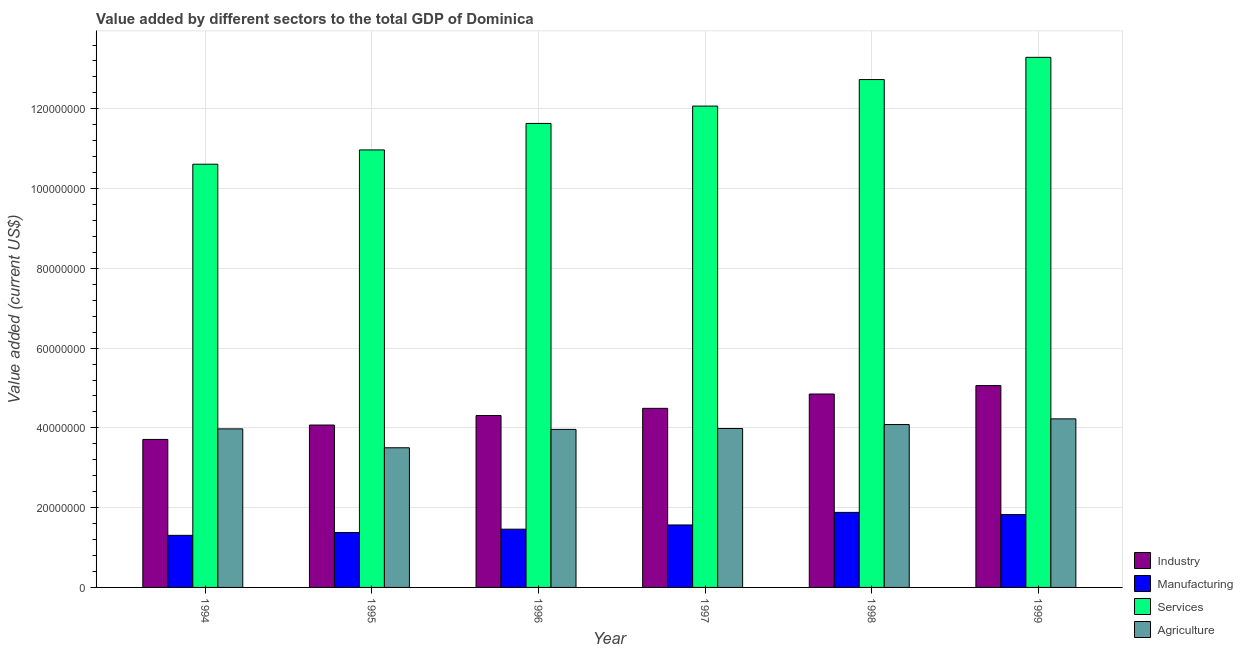How many groups of bars are there?
Your answer should be very brief. 6. Are the number of bars on each tick of the X-axis equal?
Provide a succinct answer. Yes. What is the label of the 4th group of bars from the left?
Offer a terse response. 1997. What is the value added by agricultural sector in 1994?
Your answer should be compact. 3.98e+07. Across all years, what is the maximum value added by manufacturing sector?
Your response must be concise. 1.88e+07. Across all years, what is the minimum value added by services sector?
Your answer should be very brief. 1.06e+08. In which year was the value added by agricultural sector maximum?
Offer a very short reply. 1999. What is the total value added by services sector in the graph?
Your answer should be very brief. 7.13e+08. What is the difference between the value added by industrial sector in 1995 and that in 1996?
Offer a terse response. -2.38e+06. What is the difference between the value added by services sector in 1995 and the value added by manufacturing sector in 1994?
Provide a short and direct response. 3.58e+06. What is the average value added by services sector per year?
Make the answer very short. 1.19e+08. In the year 1997, what is the difference between the value added by agricultural sector and value added by manufacturing sector?
Make the answer very short. 0. What is the ratio of the value added by industrial sector in 1995 to that in 1997?
Ensure brevity in your answer.  0.91. What is the difference between the highest and the second highest value added by services sector?
Offer a terse response. 5.57e+06. What is the difference between the highest and the lowest value added by services sector?
Make the answer very short. 2.68e+07. In how many years, is the value added by industrial sector greater than the average value added by industrial sector taken over all years?
Offer a very short reply. 3. Is it the case that in every year, the sum of the value added by services sector and value added by agricultural sector is greater than the sum of value added by manufacturing sector and value added by industrial sector?
Provide a succinct answer. Yes. What does the 2nd bar from the left in 1994 represents?
Your answer should be compact. Manufacturing. What does the 3rd bar from the right in 1997 represents?
Offer a terse response. Manufacturing. Is it the case that in every year, the sum of the value added by industrial sector and value added by manufacturing sector is greater than the value added by services sector?
Make the answer very short. No. How many years are there in the graph?
Your response must be concise. 6. What is the difference between two consecutive major ticks on the Y-axis?
Make the answer very short. 2.00e+07. Does the graph contain any zero values?
Your response must be concise. No. Does the graph contain grids?
Offer a very short reply. Yes. What is the title of the graph?
Offer a terse response. Value added by different sectors to the total GDP of Dominica. Does "Methodology assessment" appear as one of the legend labels in the graph?
Your response must be concise. No. What is the label or title of the X-axis?
Offer a very short reply. Year. What is the label or title of the Y-axis?
Keep it short and to the point. Value added (current US$). What is the Value added (current US$) in Industry in 1994?
Your answer should be very brief. 3.71e+07. What is the Value added (current US$) in Manufacturing in 1994?
Offer a very short reply. 1.31e+07. What is the Value added (current US$) of Services in 1994?
Make the answer very short. 1.06e+08. What is the Value added (current US$) in Agriculture in 1994?
Offer a very short reply. 3.98e+07. What is the Value added (current US$) of Industry in 1995?
Your answer should be compact. 4.07e+07. What is the Value added (current US$) in Manufacturing in 1995?
Your answer should be compact. 1.38e+07. What is the Value added (current US$) of Services in 1995?
Your response must be concise. 1.10e+08. What is the Value added (current US$) of Agriculture in 1995?
Give a very brief answer. 3.50e+07. What is the Value added (current US$) in Industry in 1996?
Offer a terse response. 4.31e+07. What is the Value added (current US$) in Manufacturing in 1996?
Keep it short and to the point. 1.46e+07. What is the Value added (current US$) in Services in 1996?
Offer a terse response. 1.16e+08. What is the Value added (current US$) of Agriculture in 1996?
Provide a short and direct response. 3.96e+07. What is the Value added (current US$) in Industry in 1997?
Your answer should be very brief. 4.49e+07. What is the Value added (current US$) in Manufacturing in 1997?
Give a very brief answer. 1.57e+07. What is the Value added (current US$) of Services in 1997?
Your answer should be very brief. 1.21e+08. What is the Value added (current US$) of Agriculture in 1997?
Ensure brevity in your answer.  3.98e+07. What is the Value added (current US$) in Industry in 1998?
Give a very brief answer. 4.85e+07. What is the Value added (current US$) in Manufacturing in 1998?
Provide a short and direct response. 1.88e+07. What is the Value added (current US$) in Services in 1998?
Provide a succinct answer. 1.27e+08. What is the Value added (current US$) of Agriculture in 1998?
Make the answer very short. 4.08e+07. What is the Value added (current US$) in Industry in 1999?
Your response must be concise. 5.06e+07. What is the Value added (current US$) of Manufacturing in 1999?
Keep it short and to the point. 1.83e+07. What is the Value added (current US$) of Services in 1999?
Ensure brevity in your answer.  1.33e+08. What is the Value added (current US$) in Agriculture in 1999?
Your response must be concise. 4.23e+07. Across all years, what is the maximum Value added (current US$) of Industry?
Your response must be concise. 5.06e+07. Across all years, what is the maximum Value added (current US$) of Manufacturing?
Keep it short and to the point. 1.88e+07. Across all years, what is the maximum Value added (current US$) in Services?
Give a very brief answer. 1.33e+08. Across all years, what is the maximum Value added (current US$) in Agriculture?
Provide a succinct answer. 4.23e+07. Across all years, what is the minimum Value added (current US$) of Industry?
Your response must be concise. 3.71e+07. Across all years, what is the minimum Value added (current US$) of Manufacturing?
Provide a succinct answer. 1.31e+07. Across all years, what is the minimum Value added (current US$) of Services?
Your answer should be compact. 1.06e+08. Across all years, what is the minimum Value added (current US$) of Agriculture?
Offer a very short reply. 3.50e+07. What is the total Value added (current US$) in Industry in the graph?
Make the answer very short. 2.65e+08. What is the total Value added (current US$) in Manufacturing in the graph?
Keep it short and to the point. 9.42e+07. What is the total Value added (current US$) in Services in the graph?
Provide a short and direct response. 7.13e+08. What is the total Value added (current US$) in Agriculture in the graph?
Your response must be concise. 2.37e+08. What is the difference between the Value added (current US$) of Industry in 1994 and that in 1995?
Offer a very short reply. -3.61e+06. What is the difference between the Value added (current US$) in Manufacturing in 1994 and that in 1995?
Make the answer very short. -7.04e+05. What is the difference between the Value added (current US$) in Services in 1994 and that in 1995?
Offer a very short reply. -3.58e+06. What is the difference between the Value added (current US$) in Agriculture in 1994 and that in 1995?
Provide a short and direct response. 4.74e+06. What is the difference between the Value added (current US$) of Industry in 1994 and that in 1996?
Your response must be concise. -5.99e+06. What is the difference between the Value added (current US$) in Manufacturing in 1994 and that in 1996?
Offer a very short reply. -1.54e+06. What is the difference between the Value added (current US$) in Services in 1994 and that in 1996?
Your answer should be compact. -1.02e+07. What is the difference between the Value added (current US$) of Agriculture in 1994 and that in 1996?
Provide a short and direct response. 1.30e+05. What is the difference between the Value added (current US$) in Industry in 1994 and that in 1997?
Offer a terse response. -7.80e+06. What is the difference between the Value added (current US$) of Manufacturing in 1994 and that in 1997?
Keep it short and to the point. -2.60e+06. What is the difference between the Value added (current US$) in Services in 1994 and that in 1997?
Offer a terse response. -1.46e+07. What is the difference between the Value added (current US$) in Agriculture in 1994 and that in 1997?
Offer a very short reply. -8.89e+04. What is the difference between the Value added (current US$) in Industry in 1994 and that in 1998?
Give a very brief answer. -1.14e+07. What is the difference between the Value added (current US$) in Manufacturing in 1994 and that in 1998?
Ensure brevity in your answer.  -5.75e+06. What is the difference between the Value added (current US$) in Services in 1994 and that in 1998?
Provide a short and direct response. -2.12e+07. What is the difference between the Value added (current US$) of Agriculture in 1994 and that in 1998?
Offer a terse response. -1.09e+06. What is the difference between the Value added (current US$) in Industry in 1994 and that in 1999?
Offer a terse response. -1.35e+07. What is the difference between the Value added (current US$) in Manufacturing in 1994 and that in 1999?
Keep it short and to the point. -5.20e+06. What is the difference between the Value added (current US$) of Services in 1994 and that in 1999?
Offer a terse response. -2.68e+07. What is the difference between the Value added (current US$) in Agriculture in 1994 and that in 1999?
Your response must be concise. -2.51e+06. What is the difference between the Value added (current US$) in Industry in 1995 and that in 1996?
Make the answer very short. -2.38e+06. What is the difference between the Value added (current US$) in Manufacturing in 1995 and that in 1996?
Give a very brief answer. -8.37e+05. What is the difference between the Value added (current US$) in Services in 1995 and that in 1996?
Provide a short and direct response. -6.64e+06. What is the difference between the Value added (current US$) of Agriculture in 1995 and that in 1996?
Offer a very short reply. -4.61e+06. What is the difference between the Value added (current US$) of Industry in 1995 and that in 1997?
Provide a succinct answer. -4.19e+06. What is the difference between the Value added (current US$) in Manufacturing in 1995 and that in 1997?
Your answer should be compact. -1.90e+06. What is the difference between the Value added (current US$) in Services in 1995 and that in 1997?
Offer a terse response. -1.10e+07. What is the difference between the Value added (current US$) of Agriculture in 1995 and that in 1997?
Your answer should be compact. -4.83e+06. What is the difference between the Value added (current US$) in Industry in 1995 and that in 1998?
Give a very brief answer. -7.78e+06. What is the difference between the Value added (current US$) of Manufacturing in 1995 and that in 1998?
Provide a short and direct response. -5.05e+06. What is the difference between the Value added (current US$) in Services in 1995 and that in 1998?
Provide a short and direct response. -1.76e+07. What is the difference between the Value added (current US$) in Agriculture in 1995 and that in 1998?
Give a very brief answer. -5.82e+06. What is the difference between the Value added (current US$) in Industry in 1995 and that in 1999?
Offer a very short reply. -9.89e+06. What is the difference between the Value added (current US$) in Manufacturing in 1995 and that in 1999?
Provide a succinct answer. -4.49e+06. What is the difference between the Value added (current US$) of Services in 1995 and that in 1999?
Keep it short and to the point. -2.32e+07. What is the difference between the Value added (current US$) of Agriculture in 1995 and that in 1999?
Offer a terse response. -7.25e+06. What is the difference between the Value added (current US$) of Industry in 1996 and that in 1997?
Your answer should be very brief. -1.81e+06. What is the difference between the Value added (current US$) in Manufacturing in 1996 and that in 1997?
Keep it short and to the point. -1.06e+06. What is the difference between the Value added (current US$) in Services in 1996 and that in 1997?
Provide a succinct answer. -4.35e+06. What is the difference between the Value added (current US$) of Agriculture in 1996 and that in 1997?
Make the answer very short. -2.19e+05. What is the difference between the Value added (current US$) of Industry in 1996 and that in 1998?
Offer a terse response. -5.40e+06. What is the difference between the Value added (current US$) of Manufacturing in 1996 and that in 1998?
Your answer should be compact. -4.21e+06. What is the difference between the Value added (current US$) of Services in 1996 and that in 1998?
Provide a short and direct response. -1.10e+07. What is the difference between the Value added (current US$) of Agriculture in 1996 and that in 1998?
Your response must be concise. -1.21e+06. What is the difference between the Value added (current US$) of Industry in 1996 and that in 1999?
Your response must be concise. -7.51e+06. What is the difference between the Value added (current US$) in Manufacturing in 1996 and that in 1999?
Keep it short and to the point. -3.66e+06. What is the difference between the Value added (current US$) in Services in 1996 and that in 1999?
Your answer should be very brief. -1.66e+07. What is the difference between the Value added (current US$) of Agriculture in 1996 and that in 1999?
Ensure brevity in your answer.  -2.64e+06. What is the difference between the Value added (current US$) in Industry in 1997 and that in 1998?
Offer a very short reply. -3.59e+06. What is the difference between the Value added (current US$) in Manufacturing in 1997 and that in 1998?
Your answer should be compact. -3.15e+06. What is the difference between the Value added (current US$) of Services in 1997 and that in 1998?
Provide a short and direct response. -6.65e+06. What is the difference between the Value added (current US$) of Agriculture in 1997 and that in 1998?
Offer a very short reply. -9.96e+05. What is the difference between the Value added (current US$) of Industry in 1997 and that in 1999?
Keep it short and to the point. -5.70e+06. What is the difference between the Value added (current US$) in Manufacturing in 1997 and that in 1999?
Your response must be concise. -2.60e+06. What is the difference between the Value added (current US$) in Services in 1997 and that in 1999?
Offer a very short reply. -1.22e+07. What is the difference between the Value added (current US$) of Agriculture in 1997 and that in 1999?
Provide a short and direct response. -2.42e+06. What is the difference between the Value added (current US$) of Industry in 1998 and that in 1999?
Provide a short and direct response. -2.11e+06. What is the difference between the Value added (current US$) in Manufacturing in 1998 and that in 1999?
Keep it short and to the point. 5.56e+05. What is the difference between the Value added (current US$) in Services in 1998 and that in 1999?
Provide a short and direct response. -5.57e+06. What is the difference between the Value added (current US$) of Agriculture in 1998 and that in 1999?
Offer a terse response. -1.43e+06. What is the difference between the Value added (current US$) of Industry in 1994 and the Value added (current US$) of Manufacturing in 1995?
Your answer should be very brief. 2.33e+07. What is the difference between the Value added (current US$) in Industry in 1994 and the Value added (current US$) in Services in 1995?
Give a very brief answer. -7.26e+07. What is the difference between the Value added (current US$) in Industry in 1994 and the Value added (current US$) in Agriculture in 1995?
Make the answer very short. 2.09e+06. What is the difference between the Value added (current US$) of Manufacturing in 1994 and the Value added (current US$) of Services in 1995?
Give a very brief answer. -9.66e+07. What is the difference between the Value added (current US$) in Manufacturing in 1994 and the Value added (current US$) in Agriculture in 1995?
Offer a terse response. -2.20e+07. What is the difference between the Value added (current US$) of Services in 1994 and the Value added (current US$) of Agriculture in 1995?
Keep it short and to the point. 7.11e+07. What is the difference between the Value added (current US$) of Industry in 1994 and the Value added (current US$) of Manufacturing in 1996?
Ensure brevity in your answer.  2.25e+07. What is the difference between the Value added (current US$) in Industry in 1994 and the Value added (current US$) in Services in 1996?
Ensure brevity in your answer.  -7.92e+07. What is the difference between the Value added (current US$) of Industry in 1994 and the Value added (current US$) of Agriculture in 1996?
Offer a very short reply. -2.51e+06. What is the difference between the Value added (current US$) in Manufacturing in 1994 and the Value added (current US$) in Services in 1996?
Offer a terse response. -1.03e+08. What is the difference between the Value added (current US$) in Manufacturing in 1994 and the Value added (current US$) in Agriculture in 1996?
Offer a terse response. -2.66e+07. What is the difference between the Value added (current US$) in Services in 1994 and the Value added (current US$) in Agriculture in 1996?
Make the answer very short. 6.65e+07. What is the difference between the Value added (current US$) of Industry in 1994 and the Value added (current US$) of Manufacturing in 1997?
Offer a very short reply. 2.14e+07. What is the difference between the Value added (current US$) of Industry in 1994 and the Value added (current US$) of Services in 1997?
Your response must be concise. -8.36e+07. What is the difference between the Value added (current US$) in Industry in 1994 and the Value added (current US$) in Agriculture in 1997?
Offer a terse response. -2.73e+06. What is the difference between the Value added (current US$) of Manufacturing in 1994 and the Value added (current US$) of Services in 1997?
Ensure brevity in your answer.  -1.08e+08. What is the difference between the Value added (current US$) of Manufacturing in 1994 and the Value added (current US$) of Agriculture in 1997?
Your answer should be compact. -2.68e+07. What is the difference between the Value added (current US$) of Services in 1994 and the Value added (current US$) of Agriculture in 1997?
Provide a short and direct response. 6.63e+07. What is the difference between the Value added (current US$) of Industry in 1994 and the Value added (current US$) of Manufacturing in 1998?
Give a very brief answer. 1.83e+07. What is the difference between the Value added (current US$) of Industry in 1994 and the Value added (current US$) of Services in 1998?
Give a very brief answer. -9.02e+07. What is the difference between the Value added (current US$) in Industry in 1994 and the Value added (current US$) in Agriculture in 1998?
Your answer should be compact. -3.73e+06. What is the difference between the Value added (current US$) in Manufacturing in 1994 and the Value added (current US$) in Services in 1998?
Keep it short and to the point. -1.14e+08. What is the difference between the Value added (current US$) in Manufacturing in 1994 and the Value added (current US$) in Agriculture in 1998?
Your response must be concise. -2.78e+07. What is the difference between the Value added (current US$) of Services in 1994 and the Value added (current US$) of Agriculture in 1998?
Offer a terse response. 6.53e+07. What is the difference between the Value added (current US$) in Industry in 1994 and the Value added (current US$) in Manufacturing in 1999?
Your answer should be very brief. 1.89e+07. What is the difference between the Value added (current US$) of Industry in 1994 and the Value added (current US$) of Services in 1999?
Make the answer very short. -9.58e+07. What is the difference between the Value added (current US$) in Industry in 1994 and the Value added (current US$) in Agriculture in 1999?
Your response must be concise. -5.16e+06. What is the difference between the Value added (current US$) in Manufacturing in 1994 and the Value added (current US$) in Services in 1999?
Keep it short and to the point. -1.20e+08. What is the difference between the Value added (current US$) in Manufacturing in 1994 and the Value added (current US$) in Agriculture in 1999?
Provide a succinct answer. -2.92e+07. What is the difference between the Value added (current US$) of Services in 1994 and the Value added (current US$) of Agriculture in 1999?
Your answer should be very brief. 6.39e+07. What is the difference between the Value added (current US$) of Industry in 1995 and the Value added (current US$) of Manufacturing in 1996?
Offer a terse response. 2.61e+07. What is the difference between the Value added (current US$) in Industry in 1995 and the Value added (current US$) in Services in 1996?
Ensure brevity in your answer.  -7.56e+07. What is the difference between the Value added (current US$) of Industry in 1995 and the Value added (current US$) of Agriculture in 1996?
Provide a short and direct response. 1.09e+06. What is the difference between the Value added (current US$) of Manufacturing in 1995 and the Value added (current US$) of Services in 1996?
Your answer should be compact. -1.03e+08. What is the difference between the Value added (current US$) in Manufacturing in 1995 and the Value added (current US$) in Agriculture in 1996?
Your answer should be very brief. -2.59e+07. What is the difference between the Value added (current US$) of Services in 1995 and the Value added (current US$) of Agriculture in 1996?
Provide a succinct answer. 7.01e+07. What is the difference between the Value added (current US$) in Industry in 1995 and the Value added (current US$) in Manufacturing in 1997?
Ensure brevity in your answer.  2.51e+07. What is the difference between the Value added (current US$) of Industry in 1995 and the Value added (current US$) of Services in 1997?
Your answer should be very brief. -8.00e+07. What is the difference between the Value added (current US$) of Industry in 1995 and the Value added (current US$) of Agriculture in 1997?
Give a very brief answer. 8.74e+05. What is the difference between the Value added (current US$) of Manufacturing in 1995 and the Value added (current US$) of Services in 1997?
Provide a short and direct response. -1.07e+08. What is the difference between the Value added (current US$) of Manufacturing in 1995 and the Value added (current US$) of Agriculture in 1997?
Your response must be concise. -2.61e+07. What is the difference between the Value added (current US$) of Services in 1995 and the Value added (current US$) of Agriculture in 1997?
Your answer should be compact. 6.99e+07. What is the difference between the Value added (current US$) in Industry in 1995 and the Value added (current US$) in Manufacturing in 1998?
Offer a very short reply. 2.19e+07. What is the difference between the Value added (current US$) in Industry in 1995 and the Value added (current US$) in Services in 1998?
Offer a very short reply. -8.66e+07. What is the difference between the Value added (current US$) of Industry in 1995 and the Value added (current US$) of Agriculture in 1998?
Offer a very short reply. -1.22e+05. What is the difference between the Value added (current US$) in Manufacturing in 1995 and the Value added (current US$) in Services in 1998?
Ensure brevity in your answer.  -1.14e+08. What is the difference between the Value added (current US$) in Manufacturing in 1995 and the Value added (current US$) in Agriculture in 1998?
Keep it short and to the point. -2.71e+07. What is the difference between the Value added (current US$) of Services in 1995 and the Value added (current US$) of Agriculture in 1998?
Your answer should be very brief. 6.89e+07. What is the difference between the Value added (current US$) of Industry in 1995 and the Value added (current US$) of Manufacturing in 1999?
Your answer should be very brief. 2.25e+07. What is the difference between the Value added (current US$) of Industry in 1995 and the Value added (current US$) of Services in 1999?
Your answer should be very brief. -9.22e+07. What is the difference between the Value added (current US$) of Industry in 1995 and the Value added (current US$) of Agriculture in 1999?
Offer a terse response. -1.55e+06. What is the difference between the Value added (current US$) of Manufacturing in 1995 and the Value added (current US$) of Services in 1999?
Ensure brevity in your answer.  -1.19e+08. What is the difference between the Value added (current US$) in Manufacturing in 1995 and the Value added (current US$) in Agriculture in 1999?
Offer a very short reply. -2.85e+07. What is the difference between the Value added (current US$) of Services in 1995 and the Value added (current US$) of Agriculture in 1999?
Provide a short and direct response. 6.74e+07. What is the difference between the Value added (current US$) in Industry in 1996 and the Value added (current US$) in Manufacturing in 1997?
Keep it short and to the point. 2.74e+07. What is the difference between the Value added (current US$) of Industry in 1996 and the Value added (current US$) of Services in 1997?
Your response must be concise. -7.76e+07. What is the difference between the Value added (current US$) in Industry in 1996 and the Value added (current US$) in Agriculture in 1997?
Your answer should be very brief. 3.26e+06. What is the difference between the Value added (current US$) of Manufacturing in 1996 and the Value added (current US$) of Services in 1997?
Keep it short and to the point. -1.06e+08. What is the difference between the Value added (current US$) of Manufacturing in 1996 and the Value added (current US$) of Agriculture in 1997?
Offer a very short reply. -2.52e+07. What is the difference between the Value added (current US$) of Services in 1996 and the Value added (current US$) of Agriculture in 1997?
Make the answer very short. 7.65e+07. What is the difference between the Value added (current US$) in Industry in 1996 and the Value added (current US$) in Manufacturing in 1998?
Ensure brevity in your answer.  2.43e+07. What is the difference between the Value added (current US$) in Industry in 1996 and the Value added (current US$) in Services in 1998?
Your answer should be compact. -8.42e+07. What is the difference between the Value added (current US$) in Industry in 1996 and the Value added (current US$) in Agriculture in 1998?
Offer a terse response. 2.26e+06. What is the difference between the Value added (current US$) of Manufacturing in 1996 and the Value added (current US$) of Services in 1998?
Make the answer very short. -1.13e+08. What is the difference between the Value added (current US$) in Manufacturing in 1996 and the Value added (current US$) in Agriculture in 1998?
Your answer should be very brief. -2.62e+07. What is the difference between the Value added (current US$) of Services in 1996 and the Value added (current US$) of Agriculture in 1998?
Make the answer very short. 7.55e+07. What is the difference between the Value added (current US$) of Industry in 1996 and the Value added (current US$) of Manufacturing in 1999?
Your answer should be very brief. 2.48e+07. What is the difference between the Value added (current US$) in Industry in 1996 and the Value added (current US$) in Services in 1999?
Offer a terse response. -8.98e+07. What is the difference between the Value added (current US$) in Industry in 1996 and the Value added (current US$) in Agriculture in 1999?
Ensure brevity in your answer.  8.33e+05. What is the difference between the Value added (current US$) of Manufacturing in 1996 and the Value added (current US$) of Services in 1999?
Provide a succinct answer. -1.18e+08. What is the difference between the Value added (current US$) in Manufacturing in 1996 and the Value added (current US$) in Agriculture in 1999?
Give a very brief answer. -2.77e+07. What is the difference between the Value added (current US$) in Services in 1996 and the Value added (current US$) in Agriculture in 1999?
Your answer should be compact. 7.41e+07. What is the difference between the Value added (current US$) of Industry in 1997 and the Value added (current US$) of Manufacturing in 1998?
Your response must be concise. 2.61e+07. What is the difference between the Value added (current US$) in Industry in 1997 and the Value added (current US$) in Services in 1998?
Provide a short and direct response. -8.24e+07. What is the difference between the Value added (current US$) of Industry in 1997 and the Value added (current US$) of Agriculture in 1998?
Offer a terse response. 4.07e+06. What is the difference between the Value added (current US$) of Manufacturing in 1997 and the Value added (current US$) of Services in 1998?
Provide a succinct answer. -1.12e+08. What is the difference between the Value added (current US$) in Manufacturing in 1997 and the Value added (current US$) in Agriculture in 1998?
Provide a succinct answer. -2.52e+07. What is the difference between the Value added (current US$) of Services in 1997 and the Value added (current US$) of Agriculture in 1998?
Give a very brief answer. 7.99e+07. What is the difference between the Value added (current US$) of Industry in 1997 and the Value added (current US$) of Manufacturing in 1999?
Offer a terse response. 2.66e+07. What is the difference between the Value added (current US$) in Industry in 1997 and the Value added (current US$) in Services in 1999?
Make the answer very short. -8.80e+07. What is the difference between the Value added (current US$) of Industry in 1997 and the Value added (current US$) of Agriculture in 1999?
Give a very brief answer. 2.64e+06. What is the difference between the Value added (current US$) of Manufacturing in 1997 and the Value added (current US$) of Services in 1999?
Your answer should be very brief. -1.17e+08. What is the difference between the Value added (current US$) of Manufacturing in 1997 and the Value added (current US$) of Agriculture in 1999?
Ensure brevity in your answer.  -2.66e+07. What is the difference between the Value added (current US$) in Services in 1997 and the Value added (current US$) in Agriculture in 1999?
Your answer should be very brief. 7.84e+07. What is the difference between the Value added (current US$) of Industry in 1998 and the Value added (current US$) of Manufacturing in 1999?
Make the answer very short. 3.02e+07. What is the difference between the Value added (current US$) of Industry in 1998 and the Value added (current US$) of Services in 1999?
Your answer should be compact. -8.44e+07. What is the difference between the Value added (current US$) of Industry in 1998 and the Value added (current US$) of Agriculture in 1999?
Provide a succinct answer. 6.23e+06. What is the difference between the Value added (current US$) of Manufacturing in 1998 and the Value added (current US$) of Services in 1999?
Give a very brief answer. -1.14e+08. What is the difference between the Value added (current US$) of Manufacturing in 1998 and the Value added (current US$) of Agriculture in 1999?
Make the answer very short. -2.35e+07. What is the difference between the Value added (current US$) in Services in 1998 and the Value added (current US$) in Agriculture in 1999?
Provide a short and direct response. 8.51e+07. What is the average Value added (current US$) in Industry per year?
Your answer should be very brief. 4.42e+07. What is the average Value added (current US$) of Manufacturing per year?
Provide a succinct answer. 1.57e+07. What is the average Value added (current US$) in Services per year?
Provide a short and direct response. 1.19e+08. What is the average Value added (current US$) in Agriculture per year?
Your answer should be compact. 3.96e+07. In the year 1994, what is the difference between the Value added (current US$) in Industry and Value added (current US$) in Manufacturing?
Your answer should be compact. 2.40e+07. In the year 1994, what is the difference between the Value added (current US$) in Industry and Value added (current US$) in Services?
Ensure brevity in your answer.  -6.90e+07. In the year 1994, what is the difference between the Value added (current US$) of Industry and Value added (current US$) of Agriculture?
Your answer should be very brief. -2.64e+06. In the year 1994, what is the difference between the Value added (current US$) of Manufacturing and Value added (current US$) of Services?
Provide a short and direct response. -9.31e+07. In the year 1994, what is the difference between the Value added (current US$) of Manufacturing and Value added (current US$) of Agriculture?
Your answer should be very brief. -2.67e+07. In the year 1994, what is the difference between the Value added (current US$) in Services and Value added (current US$) in Agriculture?
Your answer should be very brief. 6.64e+07. In the year 1995, what is the difference between the Value added (current US$) of Industry and Value added (current US$) of Manufacturing?
Ensure brevity in your answer.  2.70e+07. In the year 1995, what is the difference between the Value added (current US$) in Industry and Value added (current US$) in Services?
Give a very brief answer. -6.90e+07. In the year 1995, what is the difference between the Value added (current US$) in Industry and Value added (current US$) in Agriculture?
Provide a succinct answer. 5.70e+06. In the year 1995, what is the difference between the Value added (current US$) in Manufacturing and Value added (current US$) in Services?
Provide a succinct answer. -9.59e+07. In the year 1995, what is the difference between the Value added (current US$) in Manufacturing and Value added (current US$) in Agriculture?
Give a very brief answer. -2.13e+07. In the year 1995, what is the difference between the Value added (current US$) of Services and Value added (current US$) of Agriculture?
Your response must be concise. 7.47e+07. In the year 1996, what is the difference between the Value added (current US$) in Industry and Value added (current US$) in Manufacturing?
Give a very brief answer. 2.85e+07. In the year 1996, what is the difference between the Value added (current US$) of Industry and Value added (current US$) of Services?
Give a very brief answer. -7.32e+07. In the year 1996, what is the difference between the Value added (current US$) of Industry and Value added (current US$) of Agriculture?
Offer a very short reply. 3.47e+06. In the year 1996, what is the difference between the Value added (current US$) in Manufacturing and Value added (current US$) in Services?
Provide a succinct answer. -1.02e+08. In the year 1996, what is the difference between the Value added (current US$) of Manufacturing and Value added (current US$) of Agriculture?
Offer a very short reply. -2.50e+07. In the year 1996, what is the difference between the Value added (current US$) in Services and Value added (current US$) in Agriculture?
Your answer should be very brief. 7.67e+07. In the year 1997, what is the difference between the Value added (current US$) of Industry and Value added (current US$) of Manufacturing?
Provide a succinct answer. 2.92e+07. In the year 1997, what is the difference between the Value added (current US$) in Industry and Value added (current US$) in Services?
Your answer should be compact. -7.58e+07. In the year 1997, what is the difference between the Value added (current US$) in Industry and Value added (current US$) in Agriculture?
Provide a succinct answer. 5.06e+06. In the year 1997, what is the difference between the Value added (current US$) of Manufacturing and Value added (current US$) of Services?
Your response must be concise. -1.05e+08. In the year 1997, what is the difference between the Value added (current US$) in Manufacturing and Value added (current US$) in Agriculture?
Your answer should be very brief. -2.42e+07. In the year 1997, what is the difference between the Value added (current US$) in Services and Value added (current US$) in Agriculture?
Your answer should be compact. 8.08e+07. In the year 1998, what is the difference between the Value added (current US$) in Industry and Value added (current US$) in Manufacturing?
Your answer should be compact. 2.97e+07. In the year 1998, what is the difference between the Value added (current US$) of Industry and Value added (current US$) of Services?
Offer a terse response. -7.88e+07. In the year 1998, what is the difference between the Value added (current US$) of Industry and Value added (current US$) of Agriculture?
Keep it short and to the point. 7.66e+06. In the year 1998, what is the difference between the Value added (current US$) of Manufacturing and Value added (current US$) of Services?
Make the answer very short. -1.09e+08. In the year 1998, what is the difference between the Value added (current US$) of Manufacturing and Value added (current US$) of Agriculture?
Give a very brief answer. -2.20e+07. In the year 1998, what is the difference between the Value added (current US$) in Services and Value added (current US$) in Agriculture?
Offer a very short reply. 8.65e+07. In the year 1999, what is the difference between the Value added (current US$) of Industry and Value added (current US$) of Manufacturing?
Keep it short and to the point. 3.24e+07. In the year 1999, what is the difference between the Value added (current US$) of Industry and Value added (current US$) of Services?
Keep it short and to the point. -8.23e+07. In the year 1999, what is the difference between the Value added (current US$) in Industry and Value added (current US$) in Agriculture?
Give a very brief answer. 8.34e+06. In the year 1999, what is the difference between the Value added (current US$) of Manufacturing and Value added (current US$) of Services?
Provide a succinct answer. -1.15e+08. In the year 1999, what is the difference between the Value added (current US$) of Manufacturing and Value added (current US$) of Agriculture?
Give a very brief answer. -2.40e+07. In the year 1999, what is the difference between the Value added (current US$) of Services and Value added (current US$) of Agriculture?
Provide a short and direct response. 9.07e+07. What is the ratio of the Value added (current US$) of Industry in 1994 to that in 1995?
Ensure brevity in your answer.  0.91. What is the ratio of the Value added (current US$) of Manufacturing in 1994 to that in 1995?
Provide a short and direct response. 0.95. What is the ratio of the Value added (current US$) of Services in 1994 to that in 1995?
Provide a short and direct response. 0.97. What is the ratio of the Value added (current US$) in Agriculture in 1994 to that in 1995?
Ensure brevity in your answer.  1.14. What is the ratio of the Value added (current US$) in Industry in 1994 to that in 1996?
Your response must be concise. 0.86. What is the ratio of the Value added (current US$) in Manufacturing in 1994 to that in 1996?
Your response must be concise. 0.89. What is the ratio of the Value added (current US$) in Services in 1994 to that in 1996?
Give a very brief answer. 0.91. What is the ratio of the Value added (current US$) of Industry in 1994 to that in 1997?
Your response must be concise. 0.83. What is the ratio of the Value added (current US$) in Manufacturing in 1994 to that in 1997?
Provide a succinct answer. 0.83. What is the ratio of the Value added (current US$) in Services in 1994 to that in 1997?
Your response must be concise. 0.88. What is the ratio of the Value added (current US$) of Agriculture in 1994 to that in 1997?
Give a very brief answer. 1. What is the ratio of the Value added (current US$) in Industry in 1994 to that in 1998?
Make the answer very short. 0.77. What is the ratio of the Value added (current US$) of Manufacturing in 1994 to that in 1998?
Give a very brief answer. 0.69. What is the ratio of the Value added (current US$) of Services in 1994 to that in 1998?
Offer a terse response. 0.83. What is the ratio of the Value added (current US$) of Agriculture in 1994 to that in 1998?
Ensure brevity in your answer.  0.97. What is the ratio of the Value added (current US$) of Industry in 1994 to that in 1999?
Provide a succinct answer. 0.73. What is the ratio of the Value added (current US$) in Manufacturing in 1994 to that in 1999?
Your response must be concise. 0.72. What is the ratio of the Value added (current US$) of Services in 1994 to that in 1999?
Offer a terse response. 0.8. What is the ratio of the Value added (current US$) in Agriculture in 1994 to that in 1999?
Provide a short and direct response. 0.94. What is the ratio of the Value added (current US$) in Industry in 1995 to that in 1996?
Provide a short and direct response. 0.94. What is the ratio of the Value added (current US$) of Manufacturing in 1995 to that in 1996?
Provide a short and direct response. 0.94. What is the ratio of the Value added (current US$) in Services in 1995 to that in 1996?
Offer a very short reply. 0.94. What is the ratio of the Value added (current US$) in Agriculture in 1995 to that in 1996?
Keep it short and to the point. 0.88. What is the ratio of the Value added (current US$) of Industry in 1995 to that in 1997?
Your answer should be very brief. 0.91. What is the ratio of the Value added (current US$) in Manufacturing in 1995 to that in 1997?
Ensure brevity in your answer.  0.88. What is the ratio of the Value added (current US$) in Services in 1995 to that in 1997?
Your answer should be very brief. 0.91. What is the ratio of the Value added (current US$) in Agriculture in 1995 to that in 1997?
Give a very brief answer. 0.88. What is the ratio of the Value added (current US$) of Industry in 1995 to that in 1998?
Ensure brevity in your answer.  0.84. What is the ratio of the Value added (current US$) in Manufacturing in 1995 to that in 1998?
Your response must be concise. 0.73. What is the ratio of the Value added (current US$) of Services in 1995 to that in 1998?
Provide a succinct answer. 0.86. What is the ratio of the Value added (current US$) of Agriculture in 1995 to that in 1998?
Ensure brevity in your answer.  0.86. What is the ratio of the Value added (current US$) in Industry in 1995 to that in 1999?
Your response must be concise. 0.8. What is the ratio of the Value added (current US$) in Manufacturing in 1995 to that in 1999?
Your answer should be very brief. 0.75. What is the ratio of the Value added (current US$) of Services in 1995 to that in 1999?
Your answer should be compact. 0.83. What is the ratio of the Value added (current US$) in Agriculture in 1995 to that in 1999?
Give a very brief answer. 0.83. What is the ratio of the Value added (current US$) in Industry in 1996 to that in 1997?
Your answer should be very brief. 0.96. What is the ratio of the Value added (current US$) in Manufacturing in 1996 to that in 1997?
Your answer should be compact. 0.93. What is the ratio of the Value added (current US$) of Services in 1996 to that in 1997?
Make the answer very short. 0.96. What is the ratio of the Value added (current US$) in Industry in 1996 to that in 1998?
Offer a very short reply. 0.89. What is the ratio of the Value added (current US$) in Manufacturing in 1996 to that in 1998?
Your answer should be very brief. 0.78. What is the ratio of the Value added (current US$) in Services in 1996 to that in 1998?
Your answer should be compact. 0.91. What is the ratio of the Value added (current US$) in Agriculture in 1996 to that in 1998?
Offer a terse response. 0.97. What is the ratio of the Value added (current US$) of Industry in 1996 to that in 1999?
Ensure brevity in your answer.  0.85. What is the ratio of the Value added (current US$) in Manufacturing in 1996 to that in 1999?
Your response must be concise. 0.8. What is the ratio of the Value added (current US$) of Services in 1996 to that in 1999?
Provide a short and direct response. 0.88. What is the ratio of the Value added (current US$) in Agriculture in 1996 to that in 1999?
Your response must be concise. 0.94. What is the ratio of the Value added (current US$) in Industry in 1997 to that in 1998?
Your answer should be compact. 0.93. What is the ratio of the Value added (current US$) of Manufacturing in 1997 to that in 1998?
Provide a succinct answer. 0.83. What is the ratio of the Value added (current US$) in Services in 1997 to that in 1998?
Give a very brief answer. 0.95. What is the ratio of the Value added (current US$) of Agriculture in 1997 to that in 1998?
Offer a terse response. 0.98. What is the ratio of the Value added (current US$) of Industry in 1997 to that in 1999?
Provide a short and direct response. 0.89. What is the ratio of the Value added (current US$) in Manufacturing in 1997 to that in 1999?
Keep it short and to the point. 0.86. What is the ratio of the Value added (current US$) of Services in 1997 to that in 1999?
Give a very brief answer. 0.91. What is the ratio of the Value added (current US$) in Agriculture in 1997 to that in 1999?
Offer a terse response. 0.94. What is the ratio of the Value added (current US$) in Industry in 1998 to that in 1999?
Ensure brevity in your answer.  0.96. What is the ratio of the Value added (current US$) of Manufacturing in 1998 to that in 1999?
Offer a terse response. 1.03. What is the ratio of the Value added (current US$) of Services in 1998 to that in 1999?
Provide a short and direct response. 0.96. What is the ratio of the Value added (current US$) in Agriculture in 1998 to that in 1999?
Give a very brief answer. 0.97. What is the difference between the highest and the second highest Value added (current US$) of Industry?
Offer a very short reply. 2.11e+06. What is the difference between the highest and the second highest Value added (current US$) of Manufacturing?
Provide a succinct answer. 5.56e+05. What is the difference between the highest and the second highest Value added (current US$) of Services?
Provide a succinct answer. 5.57e+06. What is the difference between the highest and the second highest Value added (current US$) in Agriculture?
Give a very brief answer. 1.43e+06. What is the difference between the highest and the lowest Value added (current US$) in Industry?
Make the answer very short. 1.35e+07. What is the difference between the highest and the lowest Value added (current US$) of Manufacturing?
Offer a very short reply. 5.75e+06. What is the difference between the highest and the lowest Value added (current US$) of Services?
Offer a terse response. 2.68e+07. What is the difference between the highest and the lowest Value added (current US$) of Agriculture?
Your response must be concise. 7.25e+06. 